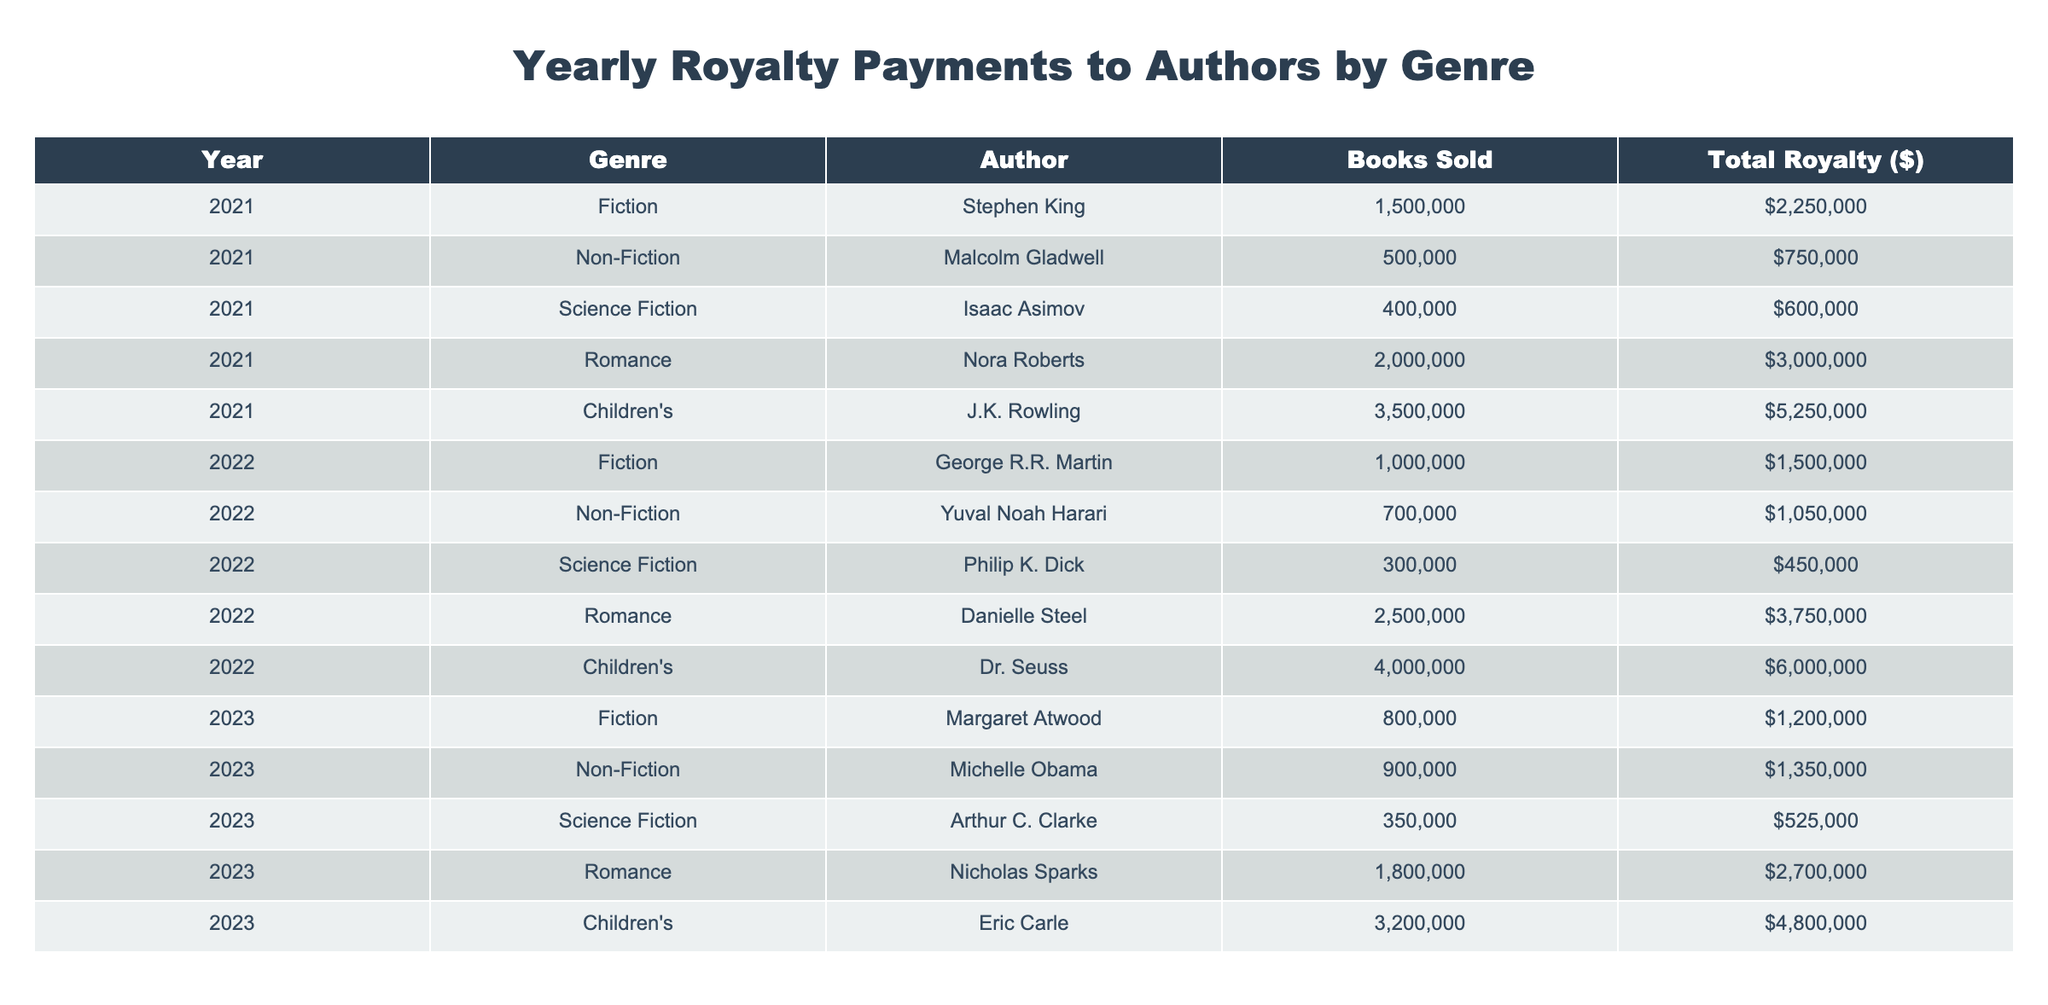What was the total royalty amount paid to J.K. Rowling in 2021? J.K. Rowling's total royalty in 2021 is explicitly listed in the "Total Royalty ($)" column for the entry where the "Author" is J.K. Rowling and the "Year" is 2021. That amount is $5,250,000.
Answer: $5,250,000 In which year did non-fiction authors receive the highest total royalty payment? To determine which year had the highest total royalties for non-fiction, we look at the "Total Royalty ($)" for non-fiction authors across years. In 2023, Michelle Obama earned $1,350,000 compared to 2021 with $750,000 and 2022 with $1,050,000. Hence, 2023 has the highest total.
Answer: 2023 What is the combined total royalty payment for all children's authors over the three years? The total royalties for children's authors include J.K. Rowling ($5,250,000 in 2021), Dr. Seuss ($6,000,000 in 2022), and Eric Carle ($4,800,000 in 2023). Adding these amounts gives $5,250,000 + $6,000,000 + $4,800,000 = $16,050,000.
Answer: $16,050,000 Did any science fiction author earn more than $600,000 in total royalty during the recorded years? Reviewing the total royalty amounts for science fiction authors reveals Isaac Asimov with $600,000 in 2021, Philip K. Dick with $450,000 in 2022, and Arthur C. Clarke with $525,000 in 2023. None of these amounts exceed $600,000, so the answer is no.
Answer: No Who was the highest-earning fiction author in the year 2022, and what was their royalty amount? The highest-earning fiction author in 2022 is George R.R. Martin, whose total royalty amount is listed as $1,500,000. This can be confirmed by looking for the highest value in the "Total Royalty ($)" column under the "Fiction" genre for the year 2022.
Answer: George R.R. Martin, $1,500,000 What is the average total royalty for romance authors across the three years? The total royalties for romance authors are Nora Roberts ($3,000,000 in 2021), Danielle Steel ($3,750,000 in 2022), and Nicholas Sparks ($2,700,000 in 2023). Summing these yields $3,000,000 + $3,750,000 + $2,700,000 = $9,450,000. The average is $9,450,000 divided by 3, which equals $3,150,000.
Answer: $3,150,000 Which genre had the highest total royalties in 2021? By aggregating the total royalties for each genre in 2021, we find: Fiction ($2,250,000), Non-Fiction ($750,000), Science Fiction ($600,000), Romance ($3,000,000), and Children's ($5,250,000). The highest total is from Children's with $5,250,000.
Answer: Children's What was the difference in total royalties between the best and worst earning genres in 2023? The best-earning genre in 2023 was Children's with $4,800,000, while the worst-earning was Science Fiction with $525,000. The difference is calculated as $4,800,000 - $525,000 = $4,275,000.
Answer: $4,275,000 